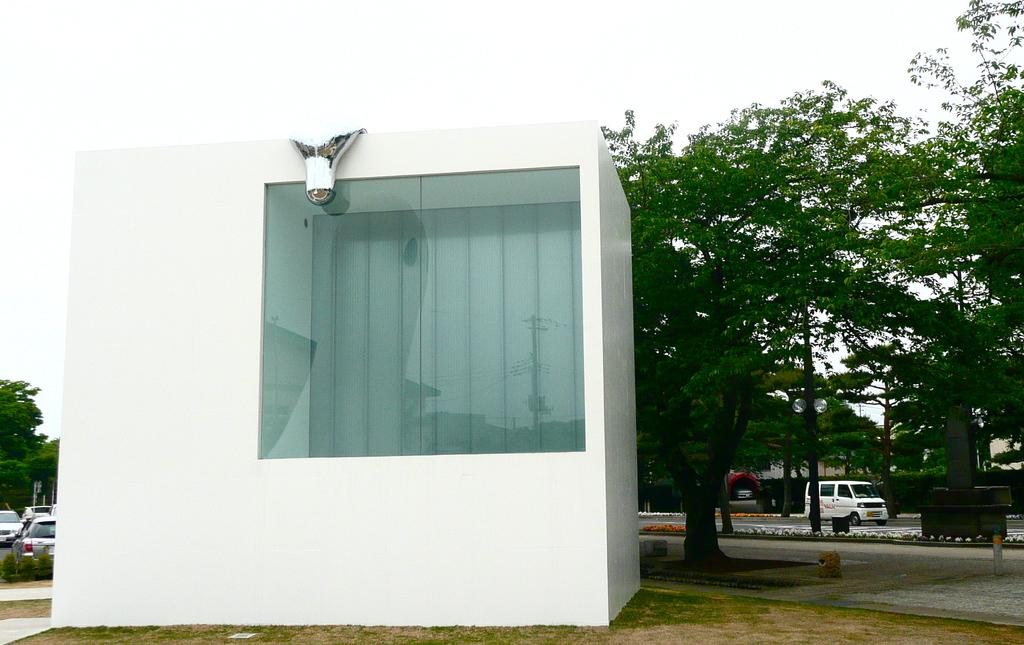What can be seen on the road in the image? There are vehicles on the road in the image. What type of room is visible in the image? There is a room with glass in the image. Can you describe the lighting in the room? There is light in the room. What type of vegetation is present in the image? There are trees and grass in the image. What structures can be seen in the image? There are poles in the image. What part of the natural environment is visible in the image? The sky is visible in the image. What verse is being recited in the image? There is no indication of any verse being recited in the image. What type of mist can be seen in the image? There is no mist present in the image. 